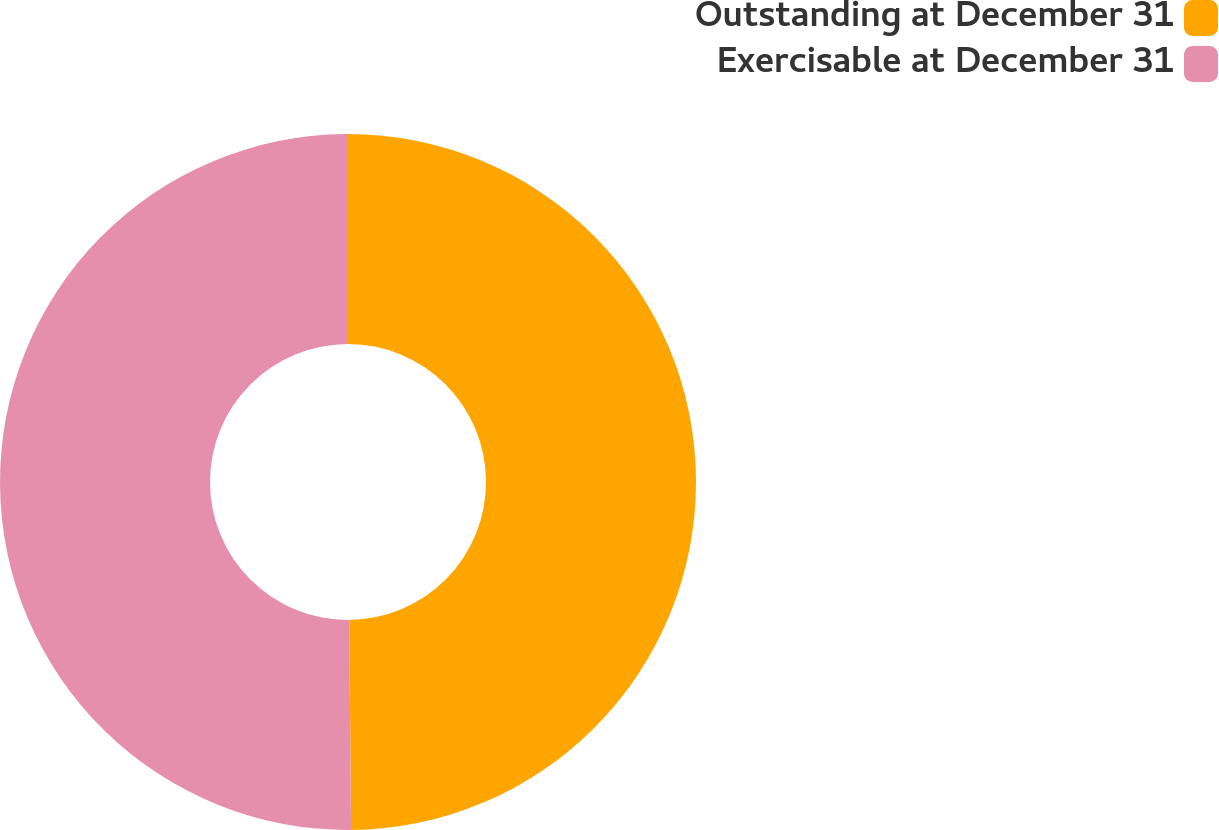Convert chart. <chart><loc_0><loc_0><loc_500><loc_500><pie_chart><fcel>Outstanding at December 31<fcel>Exercisable at December 31<nl><fcel>49.86%<fcel>50.14%<nl></chart> 